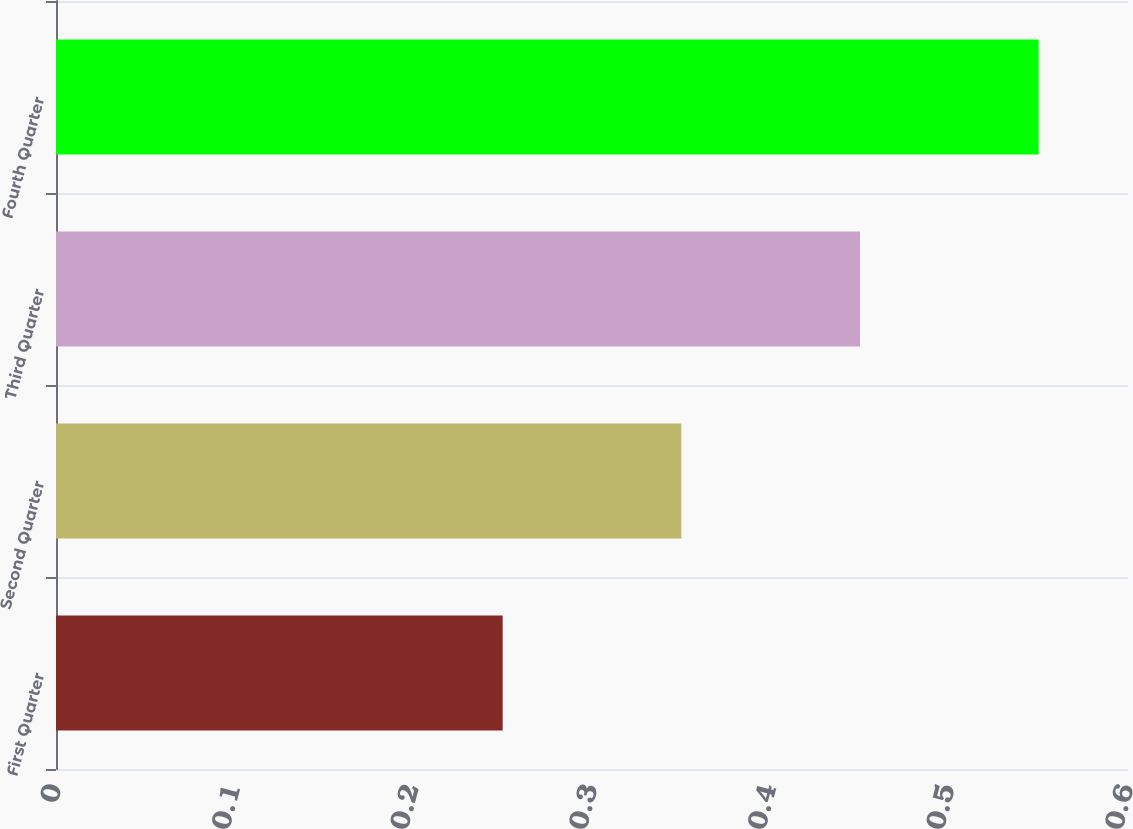Convert chart. <chart><loc_0><loc_0><loc_500><loc_500><bar_chart><fcel>First Quarter<fcel>Second Quarter<fcel>Third Quarter<fcel>Fourth Quarter<nl><fcel>0.25<fcel>0.35<fcel>0.45<fcel>0.55<nl></chart> 